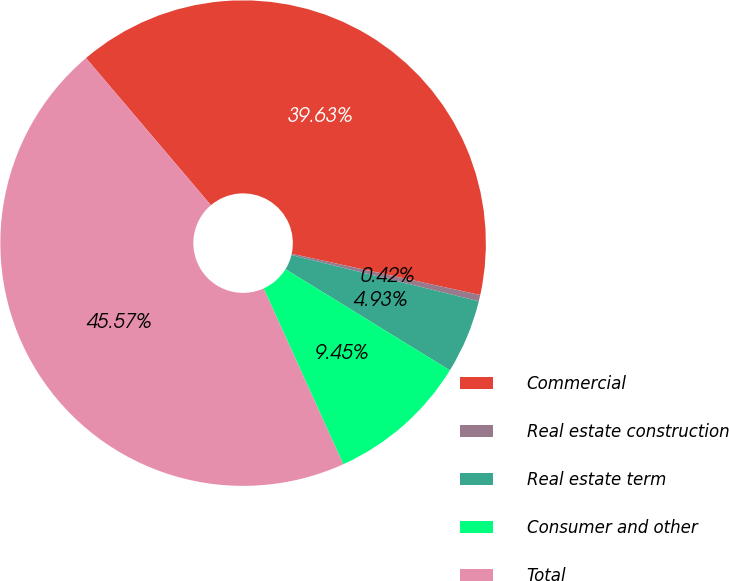Convert chart. <chart><loc_0><loc_0><loc_500><loc_500><pie_chart><fcel>Commercial<fcel>Real estate construction<fcel>Real estate term<fcel>Consumer and other<fcel>Total<nl><fcel>39.63%<fcel>0.42%<fcel>4.93%<fcel>9.45%<fcel>45.57%<nl></chart> 